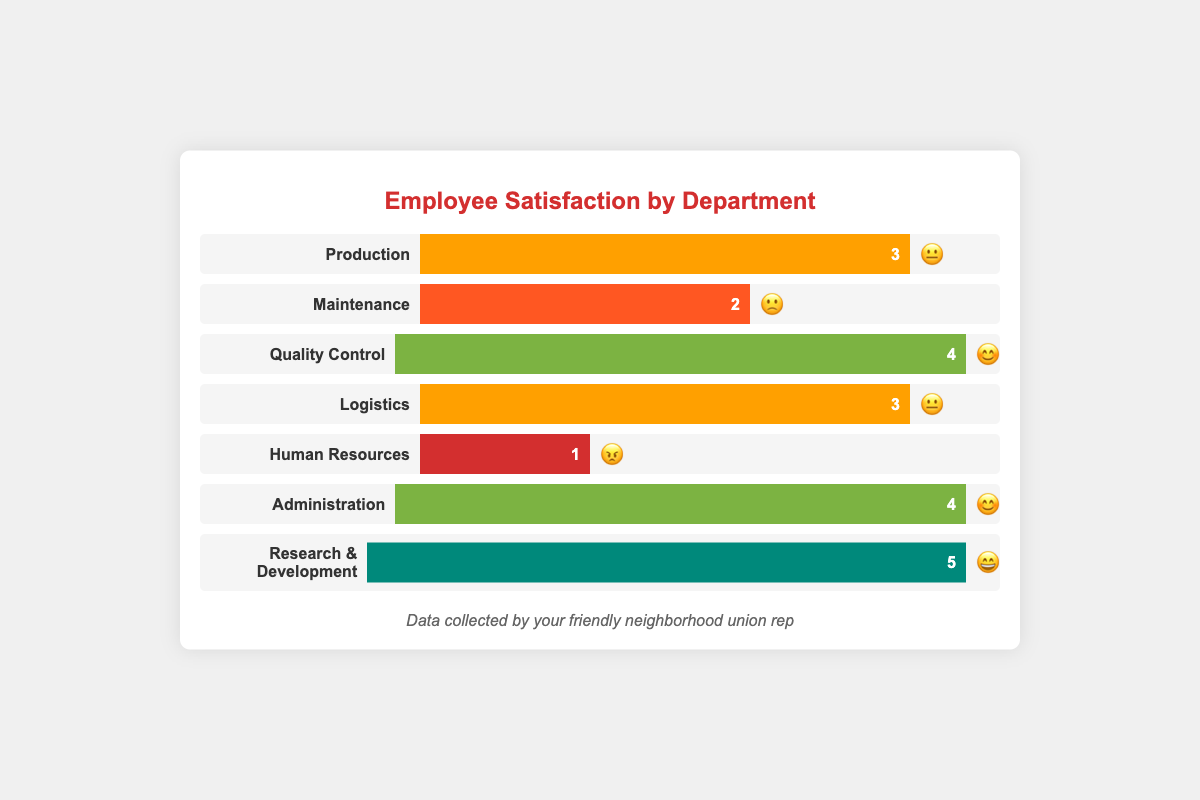What is the title of the chart? The title is displayed at the top of the chart, written in red color and larger font size.
Answer: Employee Satisfaction by Department Which department has the highest satisfaction rating? Look at the bars representing satisfaction ratings; the one with the longest bar and highest number is "Research & Development".
Answer: Research & Development What is the satisfaction rating for the Human Resources department? Find the bar labeled "Human Resources" on the left and read the number displayed inside the bar.
Answer: 1 Which departments have a satisfaction rating of 4? Identify the bars with a satisfaction rating of 4 by their length and match them to their department labels.
Answer: Quality Control, Administration What is the emoji representing the satisfaction level for Logistics? Locate the Logistics bar and observe the emoji present at the right end of the bar.
Answer: 😐 Compare the satisfaction ratings of Production and Maintenance departments. Which has a higher rating? Observe the lengths of the two bars for Production and Maintenance, and compare the numbers displayed inside.
Answer: Production What is the average satisfaction rating across all departments? Sum the satisfaction ratings of all departments (3 + 2 + 4 + 3 + 1 + 4 + 5) and divide by the number of departments (7).
Answer: 3 What is the difference in satisfaction ratings between Research & Development and Human Resources? Subtract the satisfaction rating of Human Resources from that of Research & Development (5 - 1).
Answer: 4 Which department has an emoji indicating happiness and a corresponding satisfaction rating of 4? Look for the bars with a satisfaction rating of 4 and check the emojis, find the one with a smiley face.
Answer: Quality Control, Administration List all departments with a neutral satisfaction emoji. Identify the bars with the neutral face emoji and list their corresponding departments.
Answer: Production, Logistics 